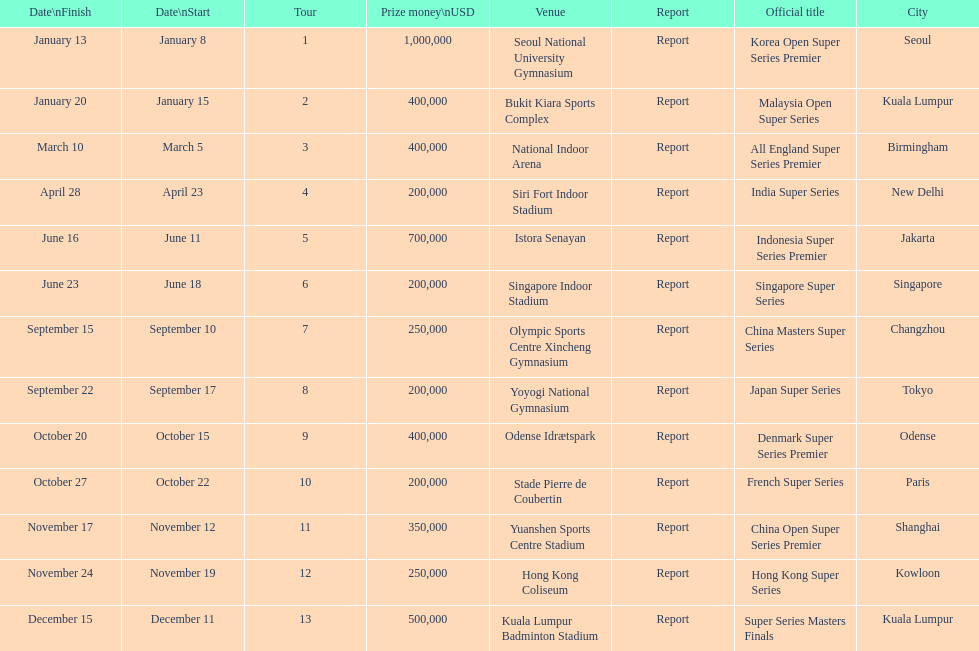How many occur in the last six months of the year? 7. 